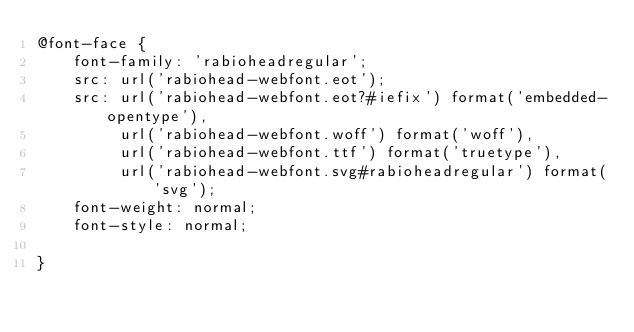Convert code to text. <code><loc_0><loc_0><loc_500><loc_500><_CSS_>@font-face {
    font-family: 'rabioheadregular';
    src: url('rabiohead-webfont.eot');
    src: url('rabiohead-webfont.eot?#iefix') format('embedded-opentype'),
         url('rabiohead-webfont.woff') format('woff'),
         url('rabiohead-webfont.ttf') format('truetype'),
         url('rabiohead-webfont.svg#rabioheadregular') format('svg');
    font-weight: normal;
    font-style: normal;

}

</code> 